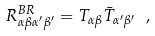<formula> <loc_0><loc_0><loc_500><loc_500>R _ { \alpha \beta \alpha ^ { \prime } \beta ^ { \prime } } ^ { B R } = T _ { \alpha \beta } \bar { T } _ { \alpha ^ { \prime } \beta ^ { \prime } } \ ,</formula> 